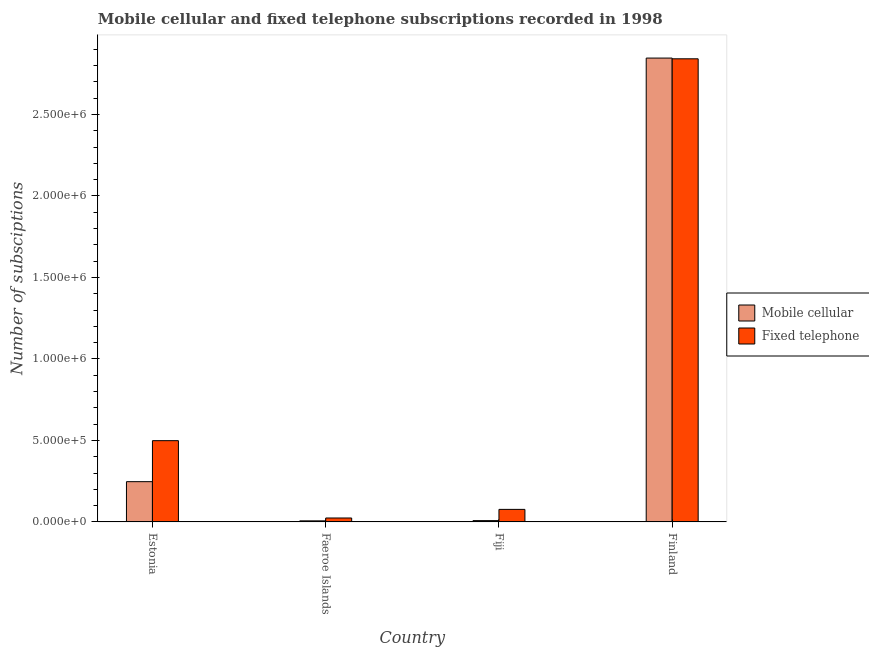How many different coloured bars are there?
Make the answer very short. 2. Are the number of bars per tick equal to the number of legend labels?
Ensure brevity in your answer.  Yes. How many bars are there on the 4th tick from the left?
Provide a short and direct response. 2. What is the label of the 3rd group of bars from the left?
Your answer should be very brief. Fiji. In how many cases, is the number of bars for a given country not equal to the number of legend labels?
Offer a terse response. 0. What is the number of fixed telephone subscriptions in Estonia?
Ensure brevity in your answer.  4.99e+05. Across all countries, what is the maximum number of mobile cellular subscriptions?
Ensure brevity in your answer.  2.85e+06. Across all countries, what is the minimum number of fixed telephone subscriptions?
Your answer should be very brief. 2.40e+04. In which country was the number of fixed telephone subscriptions maximum?
Keep it short and to the point. Finland. In which country was the number of mobile cellular subscriptions minimum?
Your response must be concise. Faeroe Islands. What is the total number of mobile cellular subscriptions in the graph?
Your answer should be compact. 3.11e+06. What is the difference between the number of fixed telephone subscriptions in Faeroe Islands and that in Fiji?
Your answer should be compact. -5.29e+04. What is the difference between the number of fixed telephone subscriptions in Faeroe Islands and the number of mobile cellular subscriptions in Finland?
Offer a very short reply. -2.82e+06. What is the average number of fixed telephone subscriptions per country?
Your answer should be compact. 8.60e+05. What is the difference between the number of fixed telephone subscriptions and number of mobile cellular subscriptions in Faeroe Islands?
Ensure brevity in your answer.  1.75e+04. In how many countries, is the number of fixed telephone subscriptions greater than 600000 ?
Offer a terse response. 1. What is the ratio of the number of fixed telephone subscriptions in Fiji to that in Finland?
Your answer should be compact. 0.03. What is the difference between the highest and the second highest number of fixed telephone subscriptions?
Keep it short and to the point. 2.34e+06. What is the difference between the highest and the lowest number of mobile cellular subscriptions?
Ensure brevity in your answer.  2.84e+06. Is the sum of the number of fixed telephone subscriptions in Fiji and Finland greater than the maximum number of mobile cellular subscriptions across all countries?
Provide a succinct answer. Yes. What does the 1st bar from the left in Estonia represents?
Offer a very short reply. Mobile cellular. What does the 1st bar from the right in Faeroe Islands represents?
Your answer should be very brief. Fixed telephone. How many bars are there?
Offer a terse response. 8. Are all the bars in the graph horizontal?
Offer a very short reply. No. How many countries are there in the graph?
Ensure brevity in your answer.  4. Does the graph contain grids?
Your answer should be very brief. No. How are the legend labels stacked?
Ensure brevity in your answer.  Vertical. What is the title of the graph?
Offer a terse response. Mobile cellular and fixed telephone subscriptions recorded in 1998. Does "Private consumption" appear as one of the legend labels in the graph?
Your answer should be compact. No. What is the label or title of the Y-axis?
Provide a short and direct response. Number of subsciptions. What is the Number of subsciptions in Mobile cellular in Estonia?
Your answer should be compact. 2.47e+05. What is the Number of subsciptions in Fixed telephone in Estonia?
Your response must be concise. 4.99e+05. What is the Number of subsciptions in Mobile cellular in Faeroe Islands?
Offer a terse response. 6516. What is the Number of subsciptions in Fixed telephone in Faeroe Islands?
Make the answer very short. 2.40e+04. What is the Number of subsciptions of Mobile cellular in Fiji?
Offer a very short reply. 8000. What is the Number of subsciptions in Fixed telephone in Fiji?
Make the answer very short. 7.69e+04. What is the Number of subsciptions in Mobile cellular in Finland?
Your answer should be compact. 2.85e+06. What is the Number of subsciptions of Fixed telephone in Finland?
Give a very brief answer. 2.84e+06. Across all countries, what is the maximum Number of subsciptions of Mobile cellular?
Offer a very short reply. 2.85e+06. Across all countries, what is the maximum Number of subsciptions in Fixed telephone?
Offer a terse response. 2.84e+06. Across all countries, what is the minimum Number of subsciptions in Mobile cellular?
Your answer should be compact. 6516. Across all countries, what is the minimum Number of subsciptions of Fixed telephone?
Make the answer very short. 2.40e+04. What is the total Number of subsciptions in Mobile cellular in the graph?
Provide a succinct answer. 3.11e+06. What is the total Number of subsciptions in Fixed telephone in the graph?
Keep it short and to the point. 3.44e+06. What is the difference between the Number of subsciptions in Mobile cellular in Estonia and that in Faeroe Islands?
Provide a succinct answer. 2.40e+05. What is the difference between the Number of subsciptions in Fixed telephone in Estonia and that in Faeroe Islands?
Offer a very short reply. 4.75e+05. What is the difference between the Number of subsciptions in Mobile cellular in Estonia and that in Fiji?
Give a very brief answer. 2.39e+05. What is the difference between the Number of subsciptions in Fixed telephone in Estonia and that in Fiji?
Provide a short and direct response. 4.22e+05. What is the difference between the Number of subsciptions in Mobile cellular in Estonia and that in Finland?
Your answer should be compact. -2.60e+06. What is the difference between the Number of subsciptions in Fixed telephone in Estonia and that in Finland?
Make the answer very short. -2.34e+06. What is the difference between the Number of subsciptions of Mobile cellular in Faeroe Islands and that in Fiji?
Provide a succinct answer. -1484. What is the difference between the Number of subsciptions of Fixed telephone in Faeroe Islands and that in Fiji?
Ensure brevity in your answer.  -5.29e+04. What is the difference between the Number of subsciptions in Mobile cellular in Faeroe Islands and that in Finland?
Your response must be concise. -2.84e+06. What is the difference between the Number of subsciptions in Fixed telephone in Faeroe Islands and that in Finland?
Your response must be concise. -2.82e+06. What is the difference between the Number of subsciptions of Mobile cellular in Fiji and that in Finland?
Your answer should be compact. -2.84e+06. What is the difference between the Number of subsciptions in Fixed telephone in Fiji and that in Finland?
Offer a very short reply. -2.76e+06. What is the difference between the Number of subsciptions of Mobile cellular in Estonia and the Number of subsciptions of Fixed telephone in Faeroe Islands?
Make the answer very short. 2.23e+05. What is the difference between the Number of subsciptions in Mobile cellular in Estonia and the Number of subsciptions in Fixed telephone in Fiji?
Provide a succinct answer. 1.70e+05. What is the difference between the Number of subsciptions in Mobile cellular in Estonia and the Number of subsciptions in Fixed telephone in Finland?
Offer a very short reply. -2.59e+06. What is the difference between the Number of subsciptions in Mobile cellular in Faeroe Islands and the Number of subsciptions in Fixed telephone in Fiji?
Give a very brief answer. -7.04e+04. What is the difference between the Number of subsciptions of Mobile cellular in Faeroe Islands and the Number of subsciptions of Fixed telephone in Finland?
Keep it short and to the point. -2.83e+06. What is the difference between the Number of subsciptions in Mobile cellular in Fiji and the Number of subsciptions in Fixed telephone in Finland?
Keep it short and to the point. -2.83e+06. What is the average Number of subsciptions of Mobile cellular per country?
Make the answer very short. 7.77e+05. What is the average Number of subsciptions of Fixed telephone per country?
Make the answer very short. 8.60e+05. What is the difference between the Number of subsciptions in Mobile cellular and Number of subsciptions in Fixed telephone in Estonia?
Your answer should be very brief. -2.52e+05. What is the difference between the Number of subsciptions in Mobile cellular and Number of subsciptions in Fixed telephone in Faeroe Islands?
Give a very brief answer. -1.75e+04. What is the difference between the Number of subsciptions in Mobile cellular and Number of subsciptions in Fixed telephone in Fiji?
Make the answer very short. -6.89e+04. What is the difference between the Number of subsciptions in Mobile cellular and Number of subsciptions in Fixed telephone in Finland?
Give a very brief answer. 4488. What is the ratio of the Number of subsciptions in Mobile cellular in Estonia to that in Faeroe Islands?
Your response must be concise. 37.91. What is the ratio of the Number of subsciptions of Fixed telephone in Estonia to that in Faeroe Islands?
Give a very brief answer. 20.75. What is the ratio of the Number of subsciptions of Mobile cellular in Estonia to that in Fiji?
Provide a short and direct response. 30.88. What is the ratio of the Number of subsciptions in Fixed telephone in Estonia to that in Fiji?
Your response must be concise. 6.48. What is the ratio of the Number of subsciptions of Mobile cellular in Estonia to that in Finland?
Make the answer very short. 0.09. What is the ratio of the Number of subsciptions in Fixed telephone in Estonia to that in Finland?
Provide a short and direct response. 0.18. What is the ratio of the Number of subsciptions of Mobile cellular in Faeroe Islands to that in Fiji?
Provide a succinct answer. 0.81. What is the ratio of the Number of subsciptions in Fixed telephone in Faeroe Islands to that in Fiji?
Your response must be concise. 0.31. What is the ratio of the Number of subsciptions in Mobile cellular in Faeroe Islands to that in Finland?
Offer a terse response. 0. What is the ratio of the Number of subsciptions of Fixed telephone in Faeroe Islands to that in Finland?
Your answer should be compact. 0.01. What is the ratio of the Number of subsciptions in Mobile cellular in Fiji to that in Finland?
Your answer should be very brief. 0. What is the ratio of the Number of subsciptions of Fixed telephone in Fiji to that in Finland?
Your response must be concise. 0.03. What is the difference between the highest and the second highest Number of subsciptions in Mobile cellular?
Provide a succinct answer. 2.60e+06. What is the difference between the highest and the second highest Number of subsciptions in Fixed telephone?
Give a very brief answer. 2.34e+06. What is the difference between the highest and the lowest Number of subsciptions of Mobile cellular?
Offer a very short reply. 2.84e+06. What is the difference between the highest and the lowest Number of subsciptions of Fixed telephone?
Offer a terse response. 2.82e+06. 